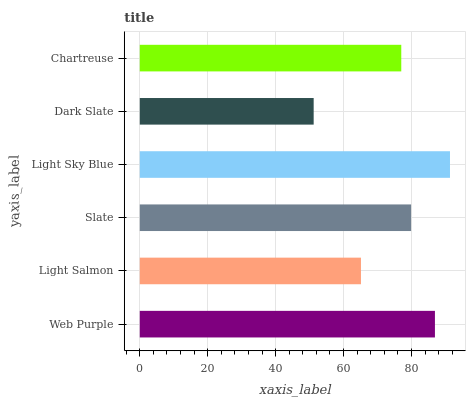Is Dark Slate the minimum?
Answer yes or no. Yes. Is Light Sky Blue the maximum?
Answer yes or no. Yes. Is Light Salmon the minimum?
Answer yes or no. No. Is Light Salmon the maximum?
Answer yes or no. No. Is Web Purple greater than Light Salmon?
Answer yes or no. Yes. Is Light Salmon less than Web Purple?
Answer yes or no. Yes. Is Light Salmon greater than Web Purple?
Answer yes or no. No. Is Web Purple less than Light Salmon?
Answer yes or no. No. Is Slate the high median?
Answer yes or no. Yes. Is Chartreuse the low median?
Answer yes or no. Yes. Is Dark Slate the high median?
Answer yes or no. No. Is Web Purple the low median?
Answer yes or no. No. 